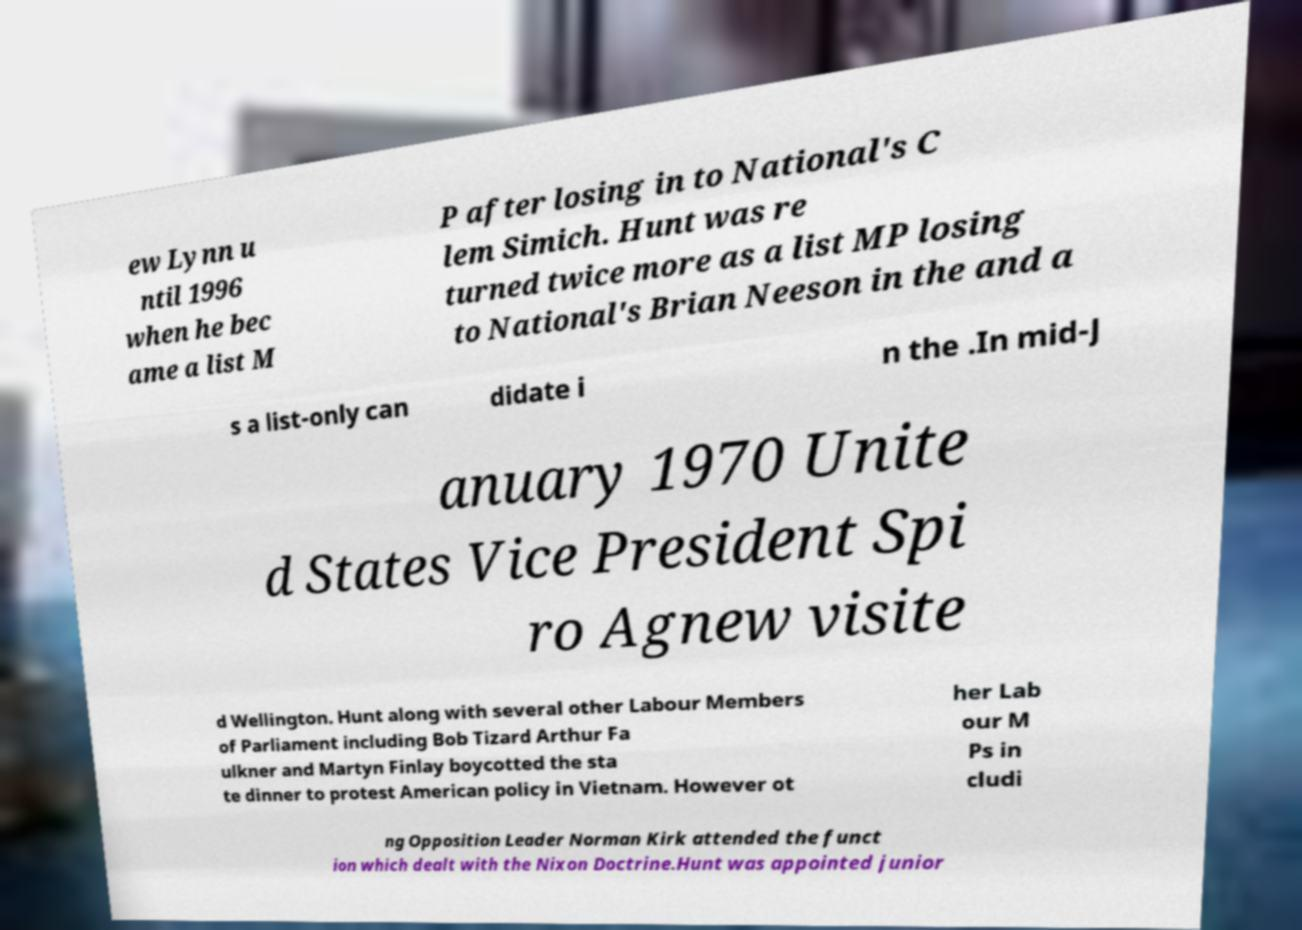I need the written content from this picture converted into text. Can you do that? ew Lynn u ntil 1996 when he bec ame a list M P after losing in to National's C lem Simich. Hunt was re turned twice more as a list MP losing to National's Brian Neeson in the and a s a list-only can didate i n the .In mid-J anuary 1970 Unite d States Vice President Spi ro Agnew visite d Wellington. Hunt along with several other Labour Members of Parliament including Bob Tizard Arthur Fa ulkner and Martyn Finlay boycotted the sta te dinner to protest American policy in Vietnam. However ot her Lab our M Ps in cludi ng Opposition Leader Norman Kirk attended the funct ion which dealt with the Nixon Doctrine.Hunt was appointed junior 